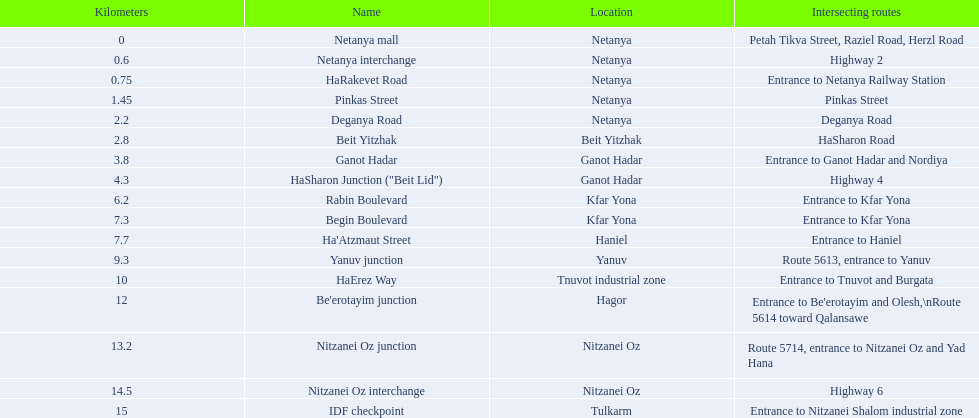What is the intersecting route of rabin boulevard? Entrance to Kfar Yona. Which portion has this intersecting route? Begin Boulevard. 